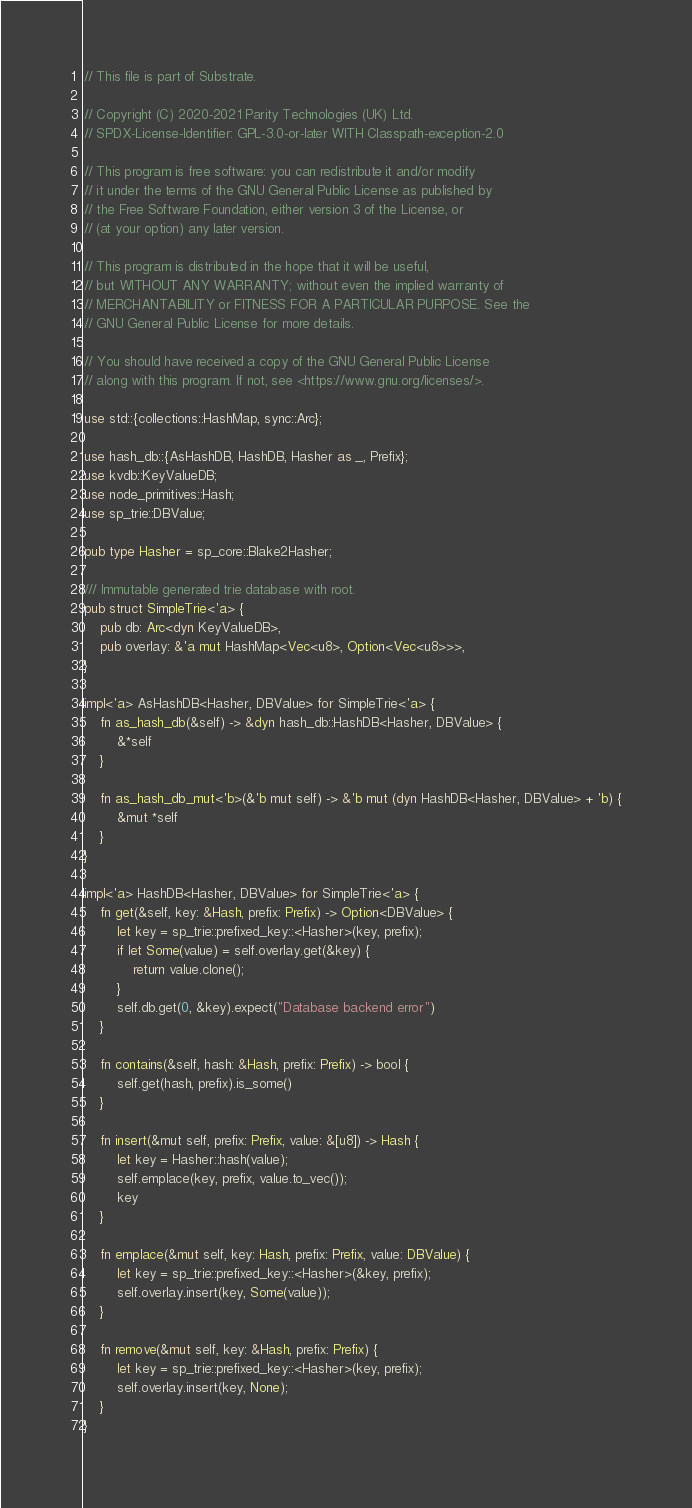Convert code to text. <code><loc_0><loc_0><loc_500><loc_500><_Rust_>// This file is part of Substrate.

// Copyright (C) 2020-2021 Parity Technologies (UK) Ltd.
// SPDX-License-Identifier: GPL-3.0-or-later WITH Classpath-exception-2.0

// This program is free software: you can redistribute it and/or modify
// it under the terms of the GNU General Public License as published by
// the Free Software Foundation, either version 3 of the License, or
// (at your option) any later version.

// This program is distributed in the hope that it will be useful,
// but WITHOUT ANY WARRANTY; without even the implied warranty of
// MERCHANTABILITY or FITNESS FOR A PARTICULAR PURPOSE. See the
// GNU General Public License for more details.

// You should have received a copy of the GNU General Public License
// along with this program. If not, see <https://www.gnu.org/licenses/>.

use std::{collections::HashMap, sync::Arc};

use hash_db::{AsHashDB, HashDB, Hasher as _, Prefix};
use kvdb::KeyValueDB;
use node_primitives::Hash;
use sp_trie::DBValue;

pub type Hasher = sp_core::Blake2Hasher;

/// Immutable generated trie database with root.
pub struct SimpleTrie<'a> {
    pub db: Arc<dyn KeyValueDB>,
    pub overlay: &'a mut HashMap<Vec<u8>, Option<Vec<u8>>>,
}

impl<'a> AsHashDB<Hasher, DBValue> for SimpleTrie<'a> {
    fn as_hash_db(&self) -> &dyn hash_db::HashDB<Hasher, DBValue> {
        &*self
    }

    fn as_hash_db_mut<'b>(&'b mut self) -> &'b mut (dyn HashDB<Hasher, DBValue> + 'b) {
        &mut *self
    }
}

impl<'a> HashDB<Hasher, DBValue> for SimpleTrie<'a> {
    fn get(&self, key: &Hash, prefix: Prefix) -> Option<DBValue> {
        let key = sp_trie::prefixed_key::<Hasher>(key, prefix);
        if let Some(value) = self.overlay.get(&key) {
            return value.clone();
        }
        self.db.get(0, &key).expect("Database backend error")
    }

    fn contains(&self, hash: &Hash, prefix: Prefix) -> bool {
        self.get(hash, prefix).is_some()
    }

    fn insert(&mut self, prefix: Prefix, value: &[u8]) -> Hash {
        let key = Hasher::hash(value);
        self.emplace(key, prefix, value.to_vec());
        key
    }

    fn emplace(&mut self, key: Hash, prefix: Prefix, value: DBValue) {
        let key = sp_trie::prefixed_key::<Hasher>(&key, prefix);
        self.overlay.insert(key, Some(value));
    }

    fn remove(&mut self, key: &Hash, prefix: Prefix) {
        let key = sp_trie::prefixed_key::<Hasher>(key, prefix);
        self.overlay.insert(key, None);
    }
}
</code> 